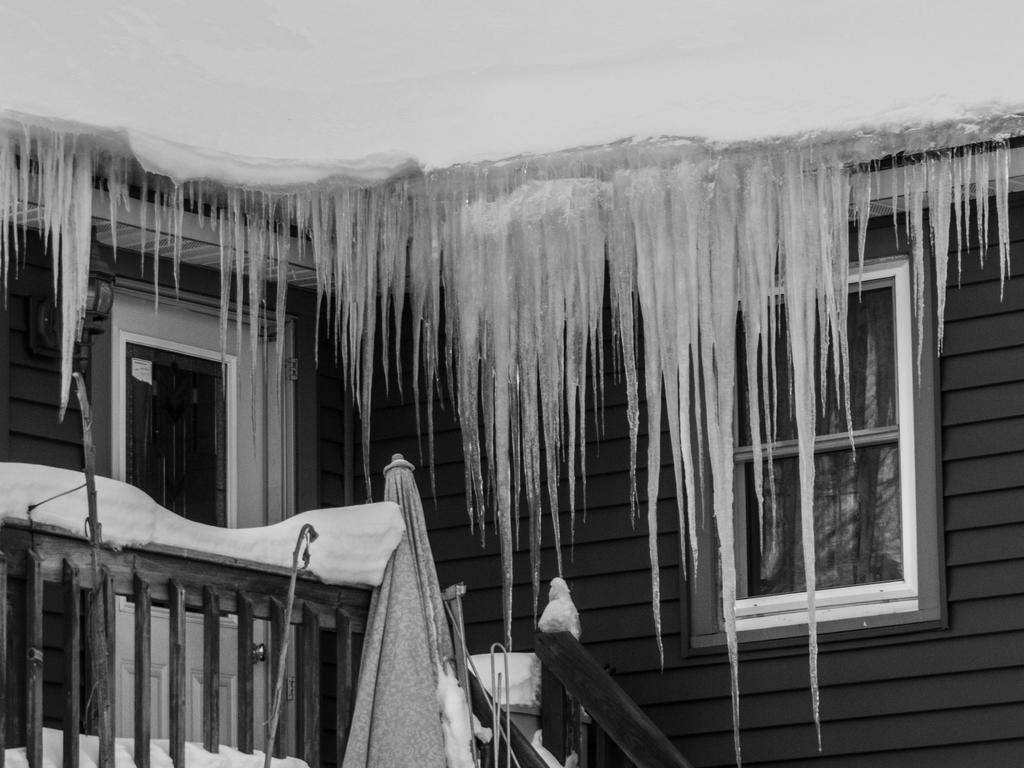What is the color scheme of the image? The image is black and white. What type of structure is visible in the image? There is a house in the image. What is covering the house in the image? The house is covered with snow. What type of wall can be seen in the image? There is a wooden wall in the image. What type of barrier is present in the image? There is a fence in the image. What object is present but not being used in the image? There is a closed umbrella in the image. What openings can be seen in the house in the image? There are windows in the image. How many cows are grazing in the image? There are no cows present in the image. Who is the expert on the snow in the image? The image does not depict an expert on the snow; it is a static representation of a snow-covered house. 